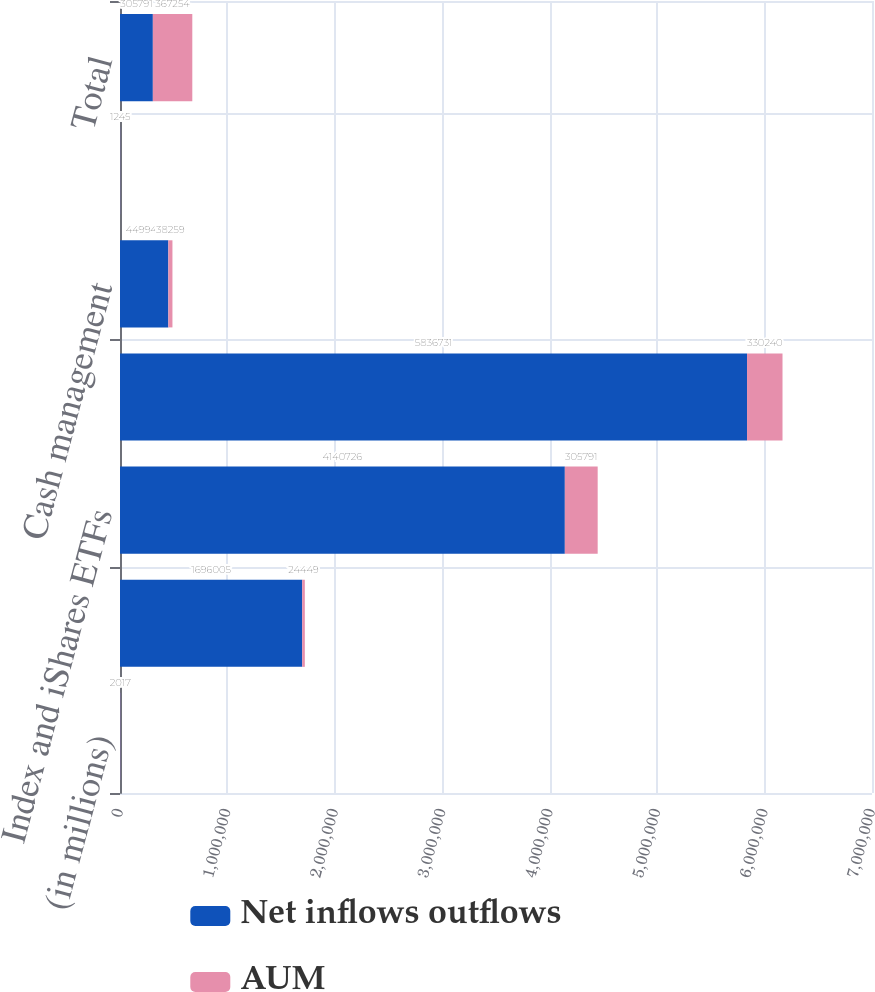<chart> <loc_0><loc_0><loc_500><loc_500><stacked_bar_chart><ecel><fcel>(in millions)<fcel>Active<fcel>Index and iShares ETFs<fcel>Long-term<fcel>Cash management<fcel>Advisory (1)<fcel>Total<nl><fcel>Net inflows outflows<fcel>2017<fcel>1.696e+06<fcel>4.14073e+06<fcel>5.83673e+06<fcel>449949<fcel>1515<fcel>305791<nl><fcel>AUM<fcel>2017<fcel>24449<fcel>305791<fcel>330240<fcel>38259<fcel>1245<fcel>367254<nl></chart> 